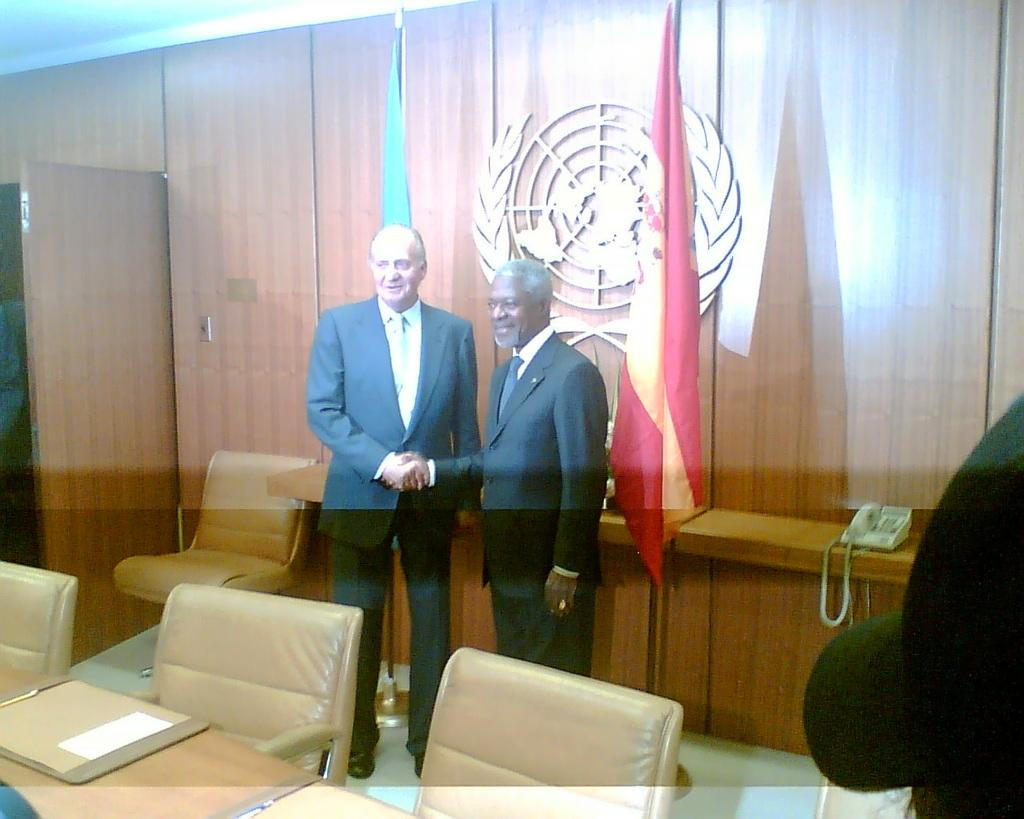How many people are in the image? There are two people in the image. What are the people doing in the image? The people are smiling and shaking hands. Can you describe the logo in the background of the image? Unfortunately, the facts provided do not give any information about the logo in the background. What type of beef is being advertised in the image? There is no beef or advertisement present in the image. How many cars can be seen in the image? There are no cars visible in the image. 